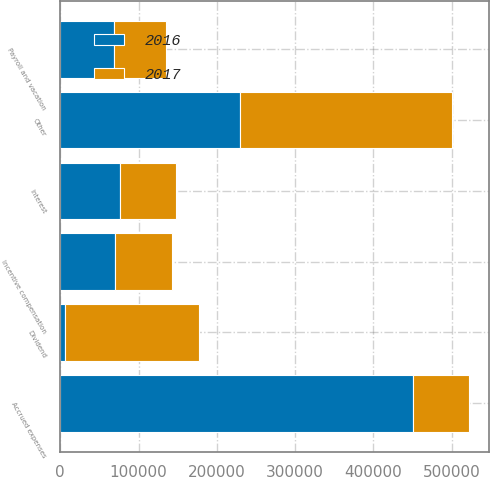Convert chart. <chart><loc_0><loc_0><loc_500><loc_500><stacked_bar_chart><ecel><fcel>Interest<fcel>Payroll and vacation<fcel>Incentive compensation<fcel>Dividend<fcel>Other<fcel>Accrued expenses<nl><fcel>2016<fcel>76615<fcel>68067<fcel>70117<fcel>5625<fcel>229833<fcel>450257<nl><fcel>2017<fcel>71176<fcel>67379<fcel>72006<fcel>172102<fcel>270483<fcel>72006<nl></chart> 